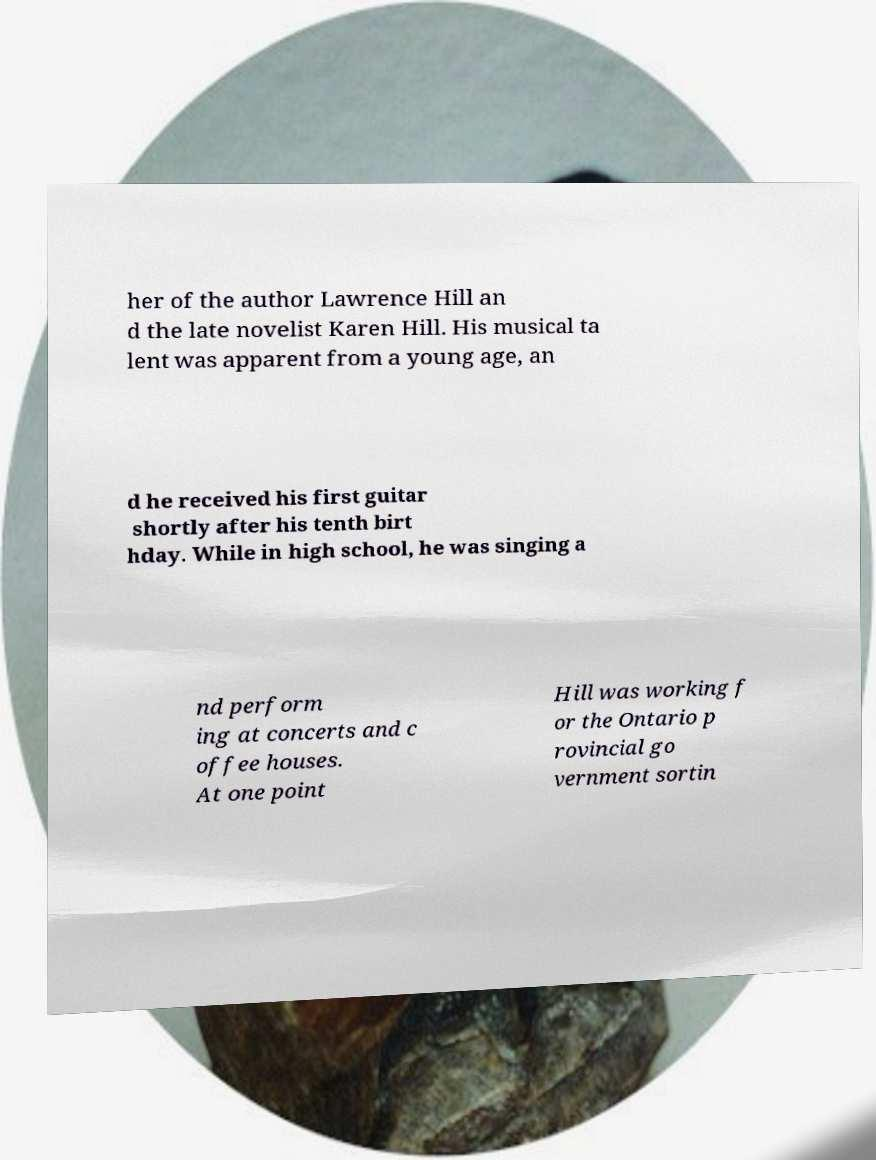What messages or text are displayed in this image? I need them in a readable, typed format. her of the author Lawrence Hill an d the late novelist Karen Hill. His musical ta lent was apparent from a young age, an d he received his first guitar shortly after his tenth birt hday. While in high school, he was singing a nd perform ing at concerts and c offee houses. At one point Hill was working f or the Ontario p rovincial go vernment sortin 